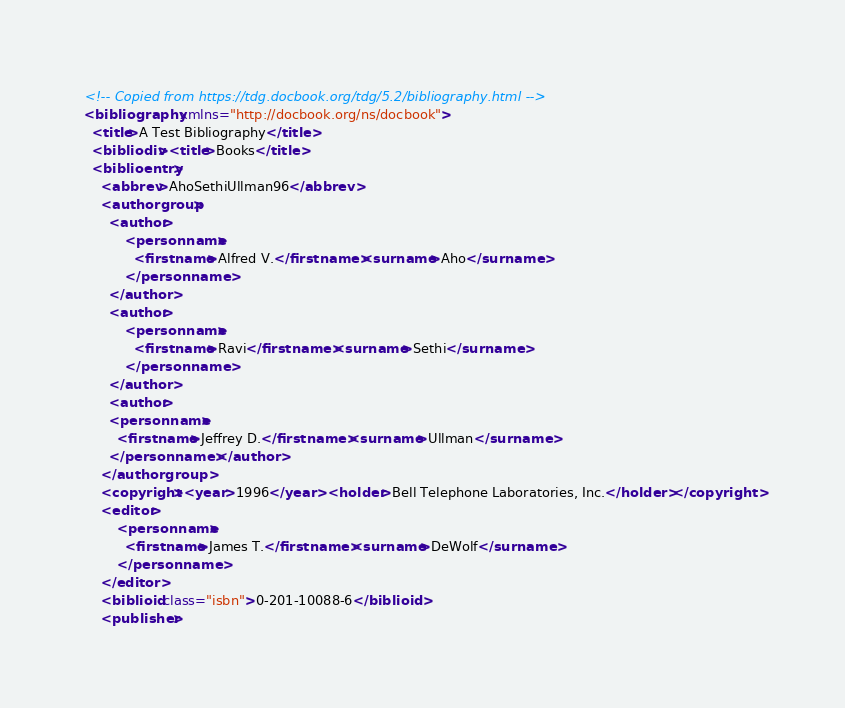Convert code to text. <code><loc_0><loc_0><loc_500><loc_500><_XML_><!-- Copied from https://tdg.docbook.org/tdg/5.2/bibliography.html -->
<bibliography xmlns="http://docbook.org/ns/docbook">
  <title>A Test Bibliography</title>
  <bibliodiv><title>Books</title>
  <biblioentry>
    <abbrev>AhoSethiUllman96</abbrev>
    <authorgroup>
      <author>
          <personname>
            <firstname>Alfred V.</firstname><surname>Aho</surname>
          </personname>
      </author>
      <author>
          <personname>
            <firstname>Ravi</firstname><surname>Sethi</surname>
          </personname>
      </author>
      <author>
      <personname>
        <firstname>Jeffrey D.</firstname><surname>Ullman</surname>
      </personname></author>
    </authorgroup>
    <copyright><year>1996</year> <holder>Bell Telephone Laboratories, Inc.</holder></copyright>
    <editor>
        <personname>
          <firstname>James T.</firstname><surname>DeWolf</surname>
        </personname>
    </editor>
    <biblioid class="isbn">0-201-10088-6</biblioid>
    <publisher></code> 